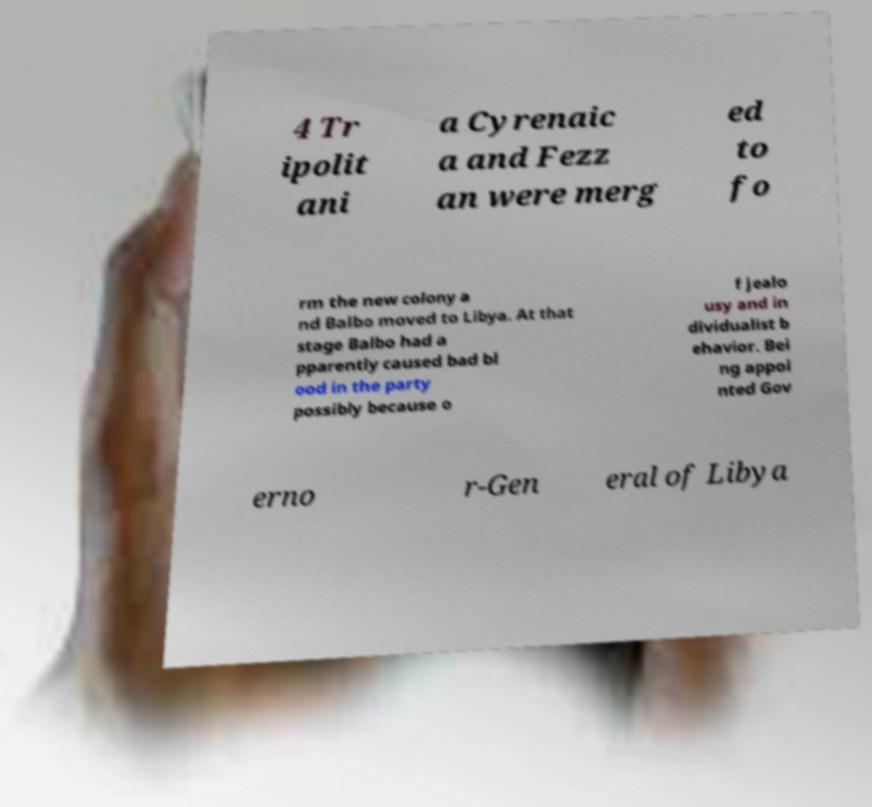Please identify and transcribe the text found in this image. 4 Tr ipolit ani a Cyrenaic a and Fezz an were merg ed to fo rm the new colony a nd Balbo moved to Libya. At that stage Balbo had a pparently caused bad bl ood in the party possibly because o f jealo usy and in dividualist b ehavior. Bei ng appoi nted Gov erno r-Gen eral of Libya 